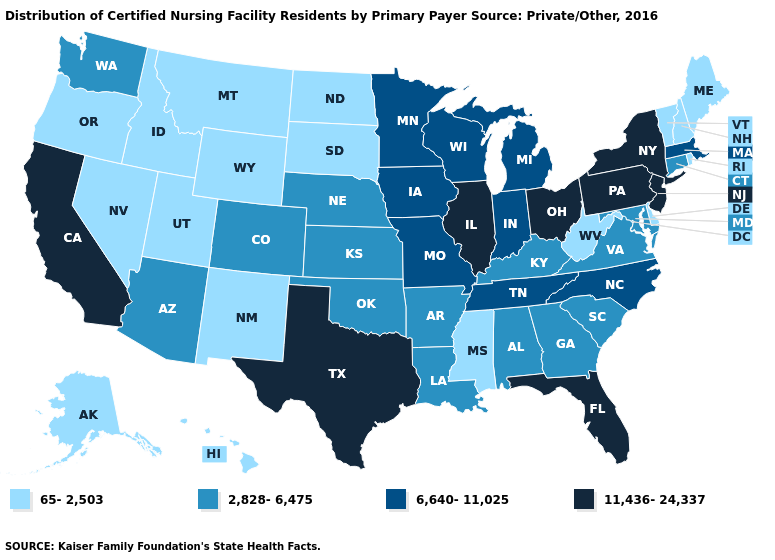What is the value of New Jersey?
Quick response, please. 11,436-24,337. What is the highest value in states that border Wisconsin?
Quick response, please. 11,436-24,337. Name the states that have a value in the range 11,436-24,337?
Keep it brief. California, Florida, Illinois, New Jersey, New York, Ohio, Pennsylvania, Texas. What is the lowest value in the West?
Be succinct. 65-2,503. Does the first symbol in the legend represent the smallest category?
Be succinct. Yes. What is the highest value in the USA?
Quick response, please. 11,436-24,337. Is the legend a continuous bar?
Give a very brief answer. No. What is the highest value in the USA?
Give a very brief answer. 11,436-24,337. What is the value of Washington?
Be succinct. 2,828-6,475. How many symbols are there in the legend?
Be succinct. 4. Does New Hampshire have a lower value than Utah?
Short answer required. No. What is the lowest value in the USA?
Give a very brief answer. 65-2,503. Does South Dakota have a lower value than Indiana?
Give a very brief answer. Yes. Which states have the lowest value in the West?
Answer briefly. Alaska, Hawaii, Idaho, Montana, Nevada, New Mexico, Oregon, Utah, Wyoming. Among the states that border North Carolina , does Tennessee have the highest value?
Answer briefly. Yes. 